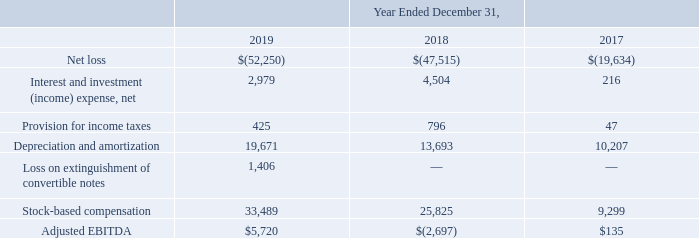Adjusted EBITDA. Adjusted EBITDA represents our net loss before interest and investment income, net and interest expense, provision for income taxes, depreciation and amortization expense, loss on extinguishment of convertible notes and stock-based compensation expense. We do not consider these items to be indicative of our core operating performance. The items that are non-cash include depreciation and amortization expense and stock-based compensation expense.
Adjusted EBITDA is a measure used by management to understand and evaluate our core operating performance and trends and to generate future operating plans, make strategic decisions regarding the allocation of capital and invest in initiatives that are focused on cultivating new markets for our solutions. In particular, the exclusion of certain expenses in calculating adjusted EBITDA facilitates comparisons of our operating performance on a period-to-period basis.
Adjusted EBITDA is not a measure calculated in accordance with GAAP. We believe that adjusted EBITDA provides useful information to investors and others in understanding and evaluating our operating results in the same manner as our management and board of directors. Nevertheless, use of adjusted EBITDA has limitations as an analytical tool, and you should not consider it in isolation or as a substitute for analysis of our financial results as reported under GAAP.
Some of these limitations are: (1) although depreciation and amortization are non-cash charges, the capitalized software that is amortized will need to be replaced in the future, and adjusted EBITDA does not reflect cash capital expenditure requirements for such replacements or for new capital expenditure requirements; (2) adjusted EBITDA does not reflect changes in, or cash requirements for, our working capital needs;
(3) adjusted EBITDA does not reflect the potentially dilutive impact of equity-based compensation; (4) adjusted EBITDA does not reflect tax payments or receipts that may represent a reduction or increase in cash
available to us; and (5) other companies, including companies in our industry, may calculate adjusted EBITDA or similarly titled measures
differently, which reduces the usefulness of the metric as a comparative measure.
Because of these and other limitations, you should consider adjusted EBITDA alongside our other GAAP-based financial performance measures, net loss and our other GAAP financial results. The following table presents a reconciliation of adjusted EBITDA to net loss, the most directly comparable GAAP measure, for each of the periods indicated (in thousands):
What does the Adjusted EBITDA represent? Adjusted ebitda represents our net loss before interest and investment income, net and interest expense, provision for income taxes, depreciation and amortization expense, loss on extinguishment of convertible notes and stock-based compensation expense. What are the non-cash items included in Adjusted EBITDA? Depreciation and amortization expense and stock-based compensation expense. What was the Net Loss in 2019, 2018 and 2017 respectively?
Answer scale should be: thousand. (52,250), (47,515), (19,634). Which year has the highest adjusted EBITDA? Locate and analyze adjusted ebitda in row 9
answer: 2019. What is the average Interest and investment (income) expense, net for 2017-2019?
Answer scale should be: thousand. (2,979 + 4,504 + 216) / 3
Answer: 2566.33. What is the change in the Provision for income taxes from 2018 to 2019?
Answer scale should be: thousand. 425 - 796
Answer: -371. 